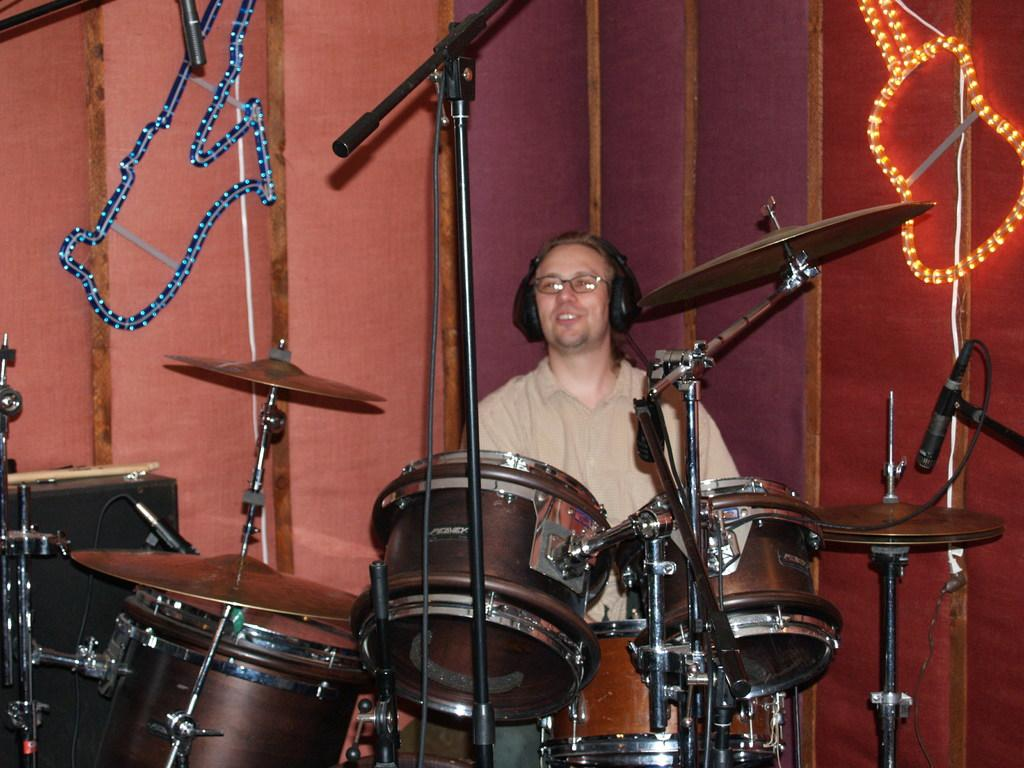What is the person in the image doing? The person in the image is playing musical instruments. What can be seen in the background of the image? There are lights and curtains in the background of the image. Where is the image taken? The image is taken on a stage. What type of fan is visible in the image? There is no fan present in the image. What idea does the person playing musical instruments have in the image? The image does not provide any information about the person's ideas or thoughts. 